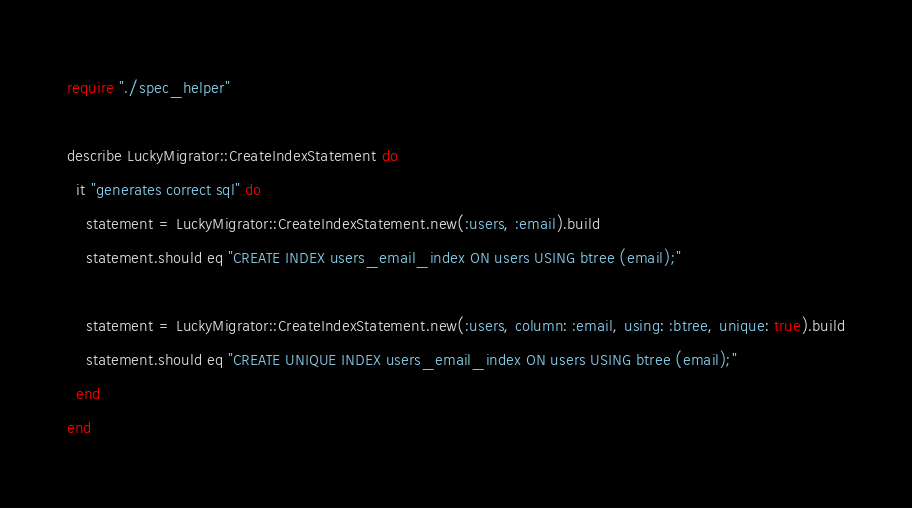<code> <loc_0><loc_0><loc_500><loc_500><_Crystal_>require "./spec_helper"

describe LuckyMigrator::CreateIndexStatement do
  it "generates correct sql" do
    statement = LuckyMigrator::CreateIndexStatement.new(:users, :email).build
    statement.should eq "CREATE INDEX users_email_index ON users USING btree (email);"

    statement = LuckyMigrator::CreateIndexStatement.new(:users, column: :email, using: :btree, unique: true).build
    statement.should eq "CREATE UNIQUE INDEX users_email_index ON users USING btree (email);"
  end
end
</code> 